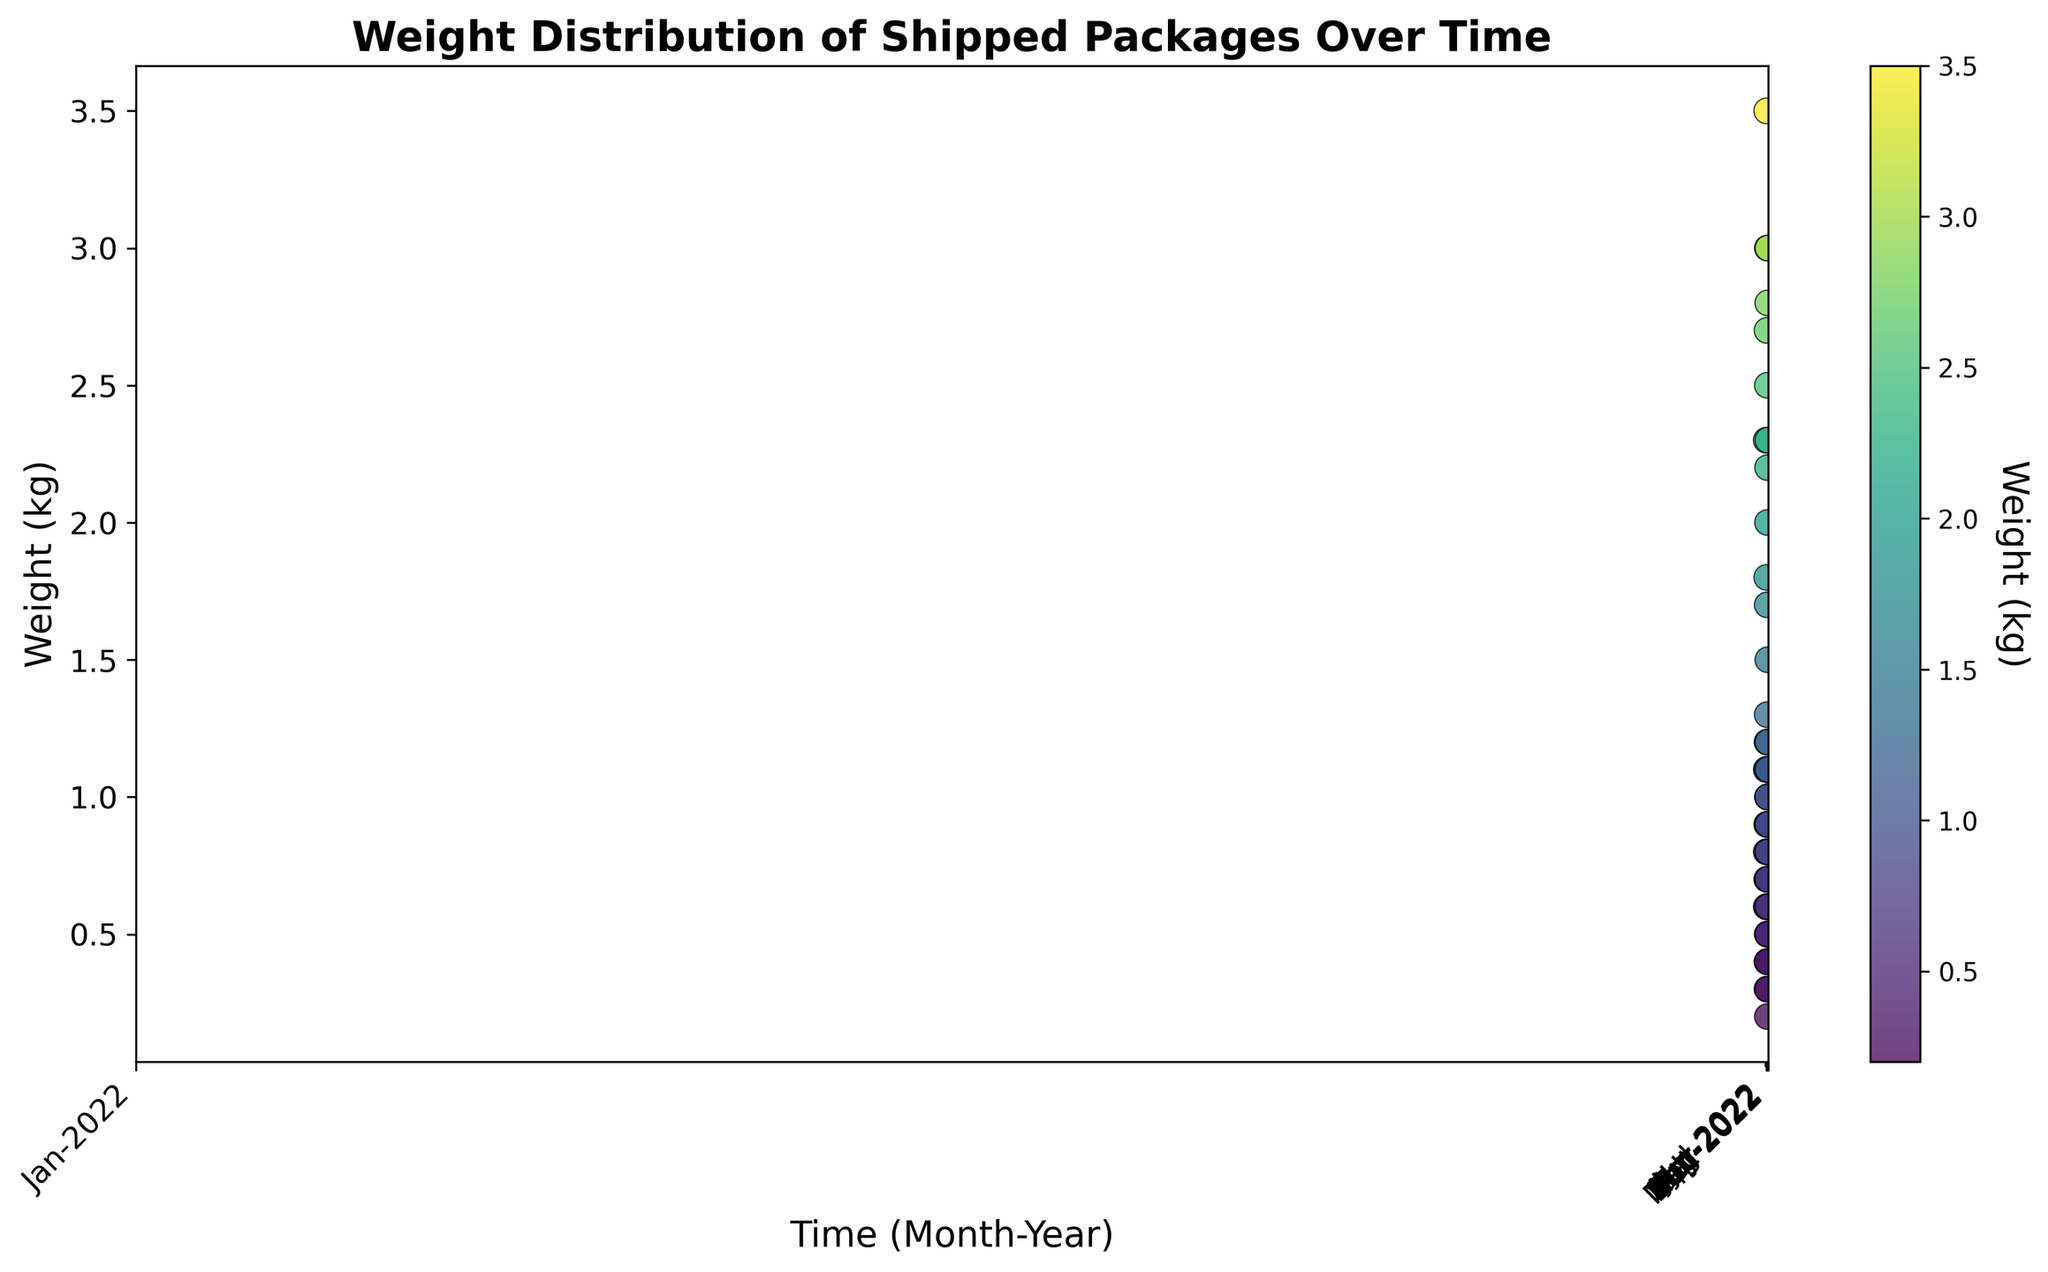What is the general trend in the weight of shipped packages over time? To see the trend, examine how the weights vary from one time period to another. Since weights are scattered across each month, it appears there is no clear upward or downward trend over time. The weights fluctuate within a similar range (approximately 0.2 kg to 3.5 kg) throughout the period.
Answer: Fluctuating, no clear trend Which month appears to have the heaviest package shipped? Check for the most extreme values on the y-axis (weight in kg). March 2022 shows a package weighing 3.5 kg, which is the highest weight observed on the chart.
Answer: March 2022 In which month did you ship the lightest package? Look for the smallest value on the y-axis (weight in kg). Both January 2022 and June 2022 have the minimum weight observed, which is 0.2 kg.
Answer: January 2022 and June 2022 How does the average weight of packages shipped in January 2022 compare to February 2022? Calculate the average weight for both months. January 2022: (0.5 + 1.0 + 0.2 + 2.3)/4 = 1.0 kg; February 2022: (0.8 + 2.3 + 0.6 + 1.1)/4 = 1.2 kg. The average weight in February 2022 is slightly higher.
Answer: February 2022 has a higher average weight Are there more packages weighing above 1.5 kg in the March 2022 or October 2022? Count the number of packages above 1.5 kg. March 2022: Two packages (1.8 kg, 3.5 kg); October 2022: Two packages (2.8 kg, 1.5 kg). The counts are the same.
Answer: Same number Which month shows the highest concentration of packages weighing under 1 kg? Identify months where multiple packages cluster below 1 kg on the y-axis. April 2022 has several packages under 1 kg (0.4 kg, 0.3 kg, 0.2 kg).
Answer: April 2022 Did packages shipped in December 2022 have more variation in weight compared to May 2022? Compare the spread of weights on the y-axis for both months. December 2022 weights range from 0.9 kg to 3.0 kg, while May 2022 weights range from 0.4 kg to 1.7 kg. December 2022 shows a greater range and thus more variation.
Answer: December 2022 Which month showed package weights closest to its average? Calculate the average weight and compare individual weights' proximity to it. For example, for January 2022: avg = 1.0 kg; individual weights: (0.5, 1.0, 0.2, 2.3). February 2022 average is closer in individual weights, with an average of 1.2 kg and packages like 1.1 kg and 0.6 kg near the average.
Answer: February 2022 In which month did you ship two packages with the same weight? Look for data points at the same y-axis position for any given month. April 2022 has two packages both weighing 0.4 kg.
Answer: April 2022 